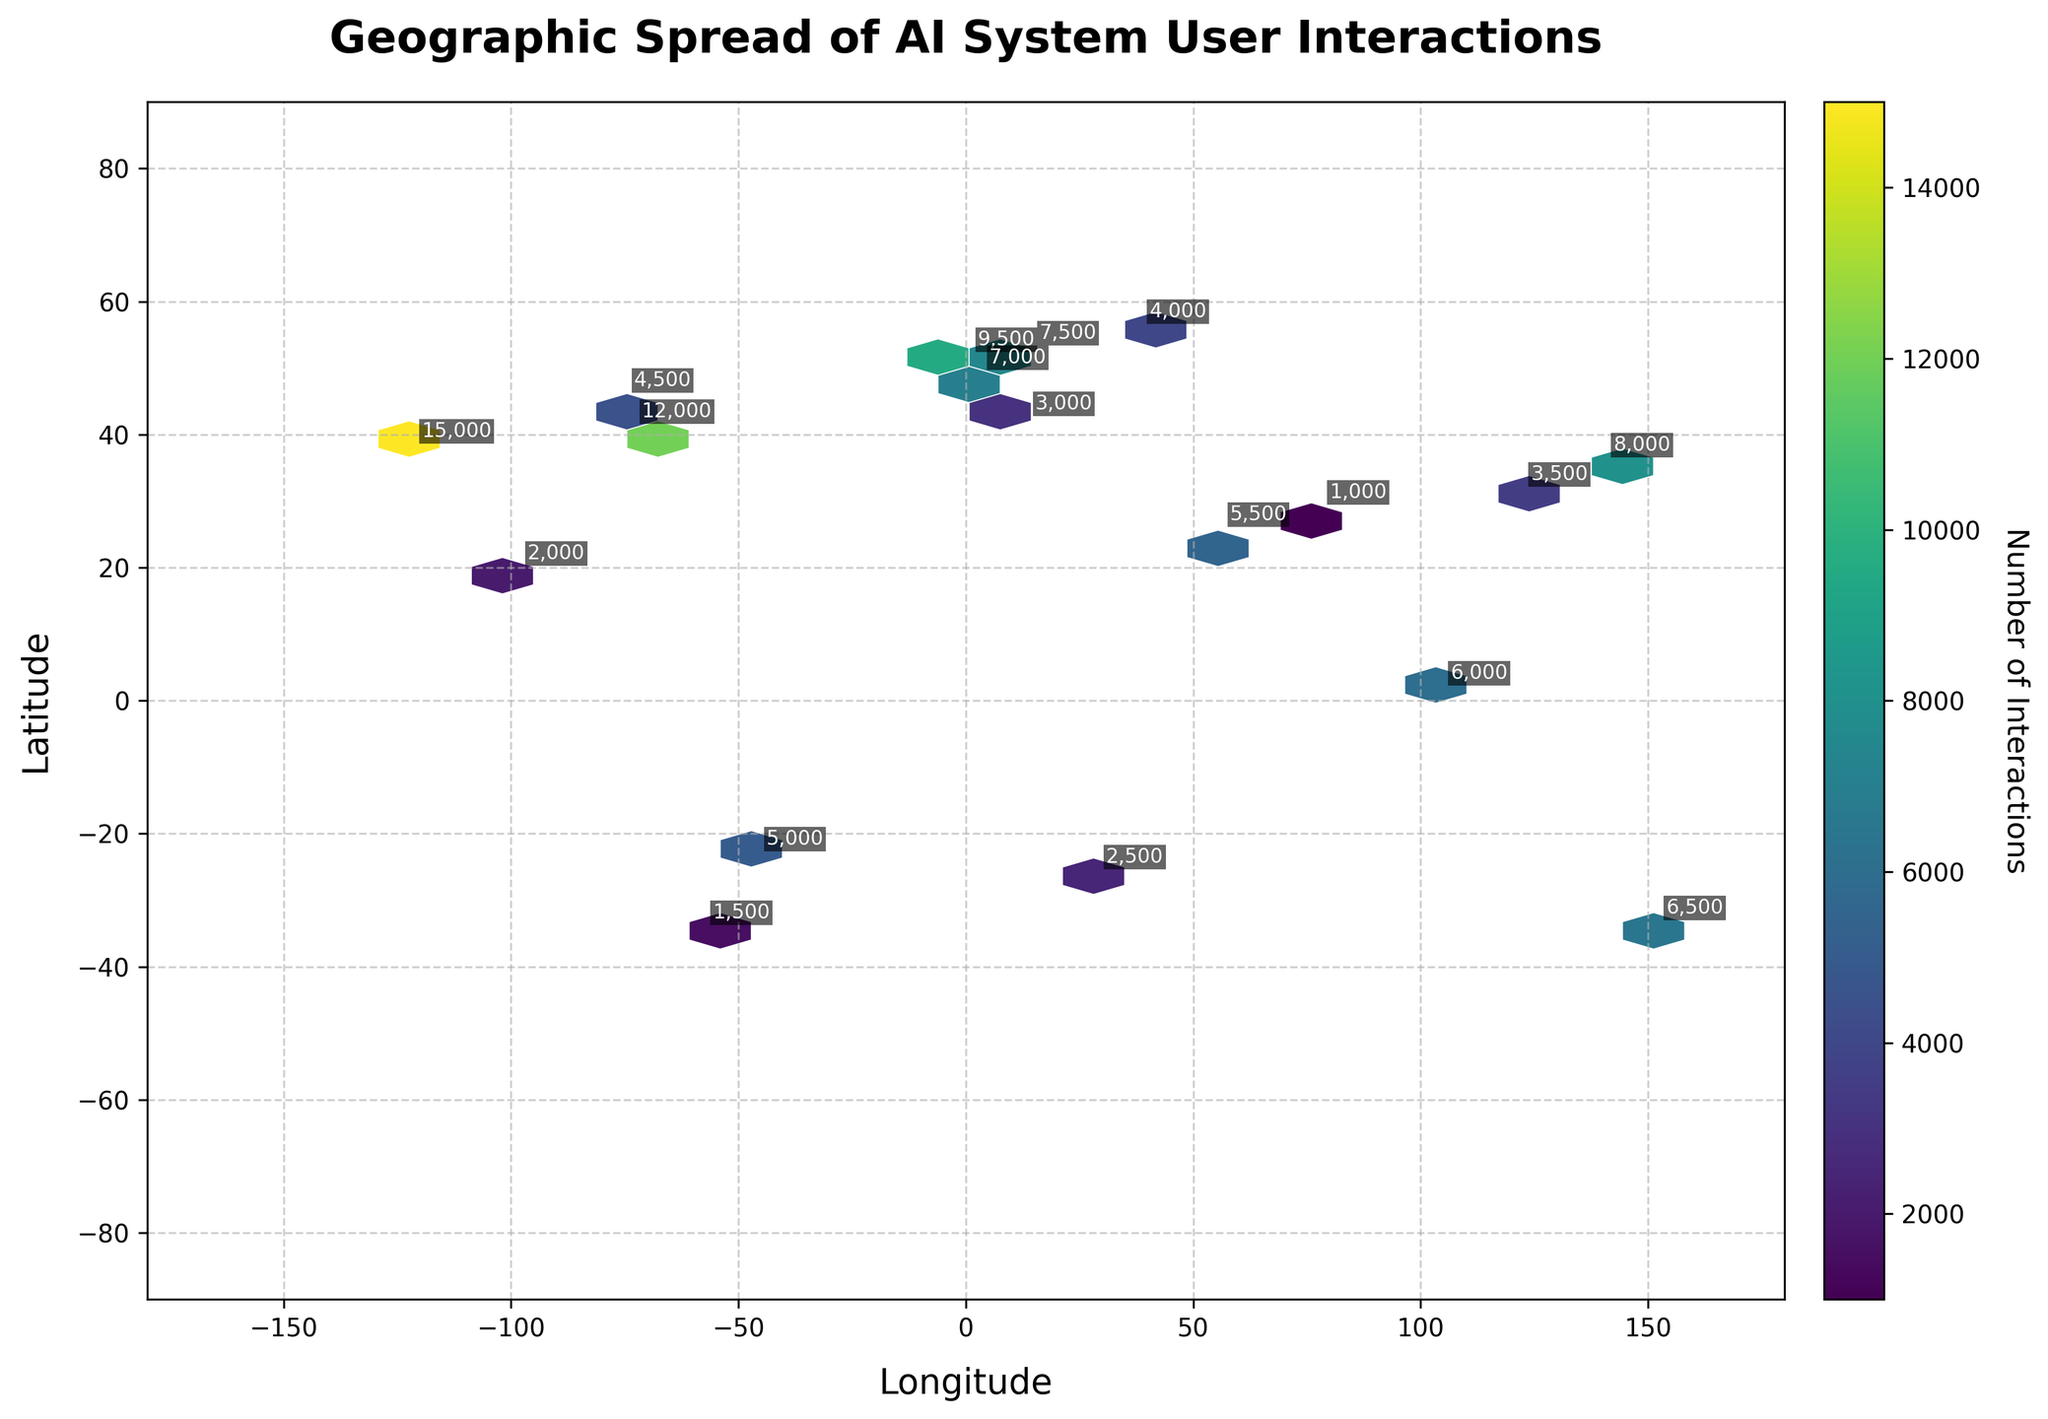What is the title of the figure? The title of the figure is displayed at the top and reads 'Geographic Spread of AI System User Interactions'.
Answer: Geographic Spread of AI System User Interactions What is the range of the x-axis? The x-axis represents the longitude values, and it ranges from -180 to 180, as indicated by the x-axis limits.
Answer: -180 to 180 How many hexagons are there on the plot? The plot contains a hexbin plot, and by observing the figure, one can count the number of hexagons visually. However, there are too many hexagons to count directly without more specific analytical tools.
Answer: Not directly countable Which city has the highest number of interactions? The highest number of interactions is denoted by both the hexagon with the highest color intensity and the label annotation. From the annotations, San Francisco (37.7749, -122.4194) with 15,000 interactions has the highest.
Answer: San Francisco Which two cities have the closest interaction counts? Looking at the annotations, Berlin (7,500) and Paris (7,000) have the closet number of interactions among the cities, differing by just 500 interactions.
Answer: Berlin and Paris How does the interaction count in Tokyo compare to that in Singapore? Tokyo has 8,000 interactions, while Singapore has 6,000 interactions, so Tokyo has more interactions than Singapore.
Answer: Tokyo has more interactions What is the color indicating the highest number of interactions in the hexbin plot? The hexbin plot uses a 'viridis' color map, where the highest number of interactions would be represented by a dark purple color. This is evident in the hexbin corresponding to San Francisco.
Answer: Dark purple What city has 3,500 interactions, and in which country is it located? The city with 3,500 interactions is Shanghai, identified by the annotation at coordinates (31.2304, 121.4737), which is located in China.
Answer: Shanghai, China What is the typical grid size used in the hexbin plot, based on the visual grid spacing? The visual grid spacing of hexagons around each data point suggests a gridsize of about 20, creating a moderately dense network of hexagons to represent geographical spread.
Answer: Grid size of about 20 